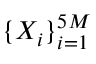<formula> <loc_0><loc_0><loc_500><loc_500>\{ X _ { i } \} _ { i = 1 } ^ { 5 M }</formula> 